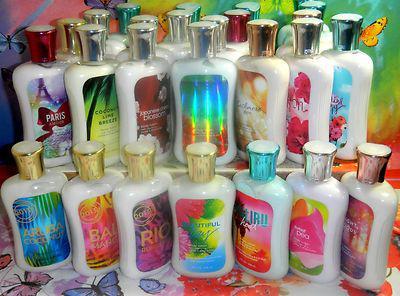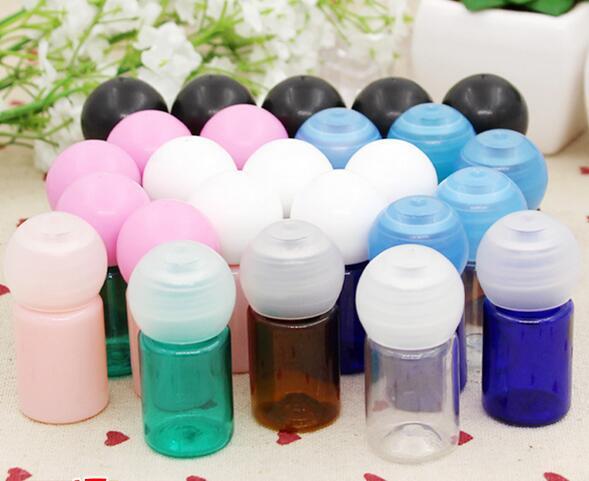The first image is the image on the left, the second image is the image on the right. Given the left and right images, does the statement "The bottles in the image on the left are stacked in a tiered display." hold true? Answer yes or no. Yes. 